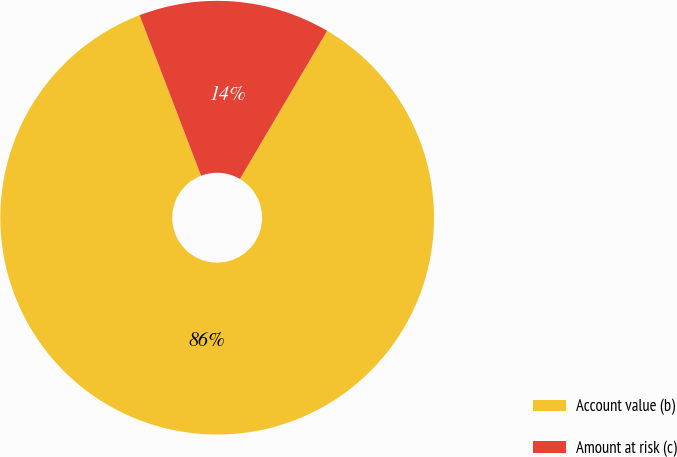<chart> <loc_0><loc_0><loc_500><loc_500><pie_chart><fcel>Account value (b)<fcel>Amount at risk (c)<nl><fcel>85.71%<fcel>14.29%<nl></chart> 